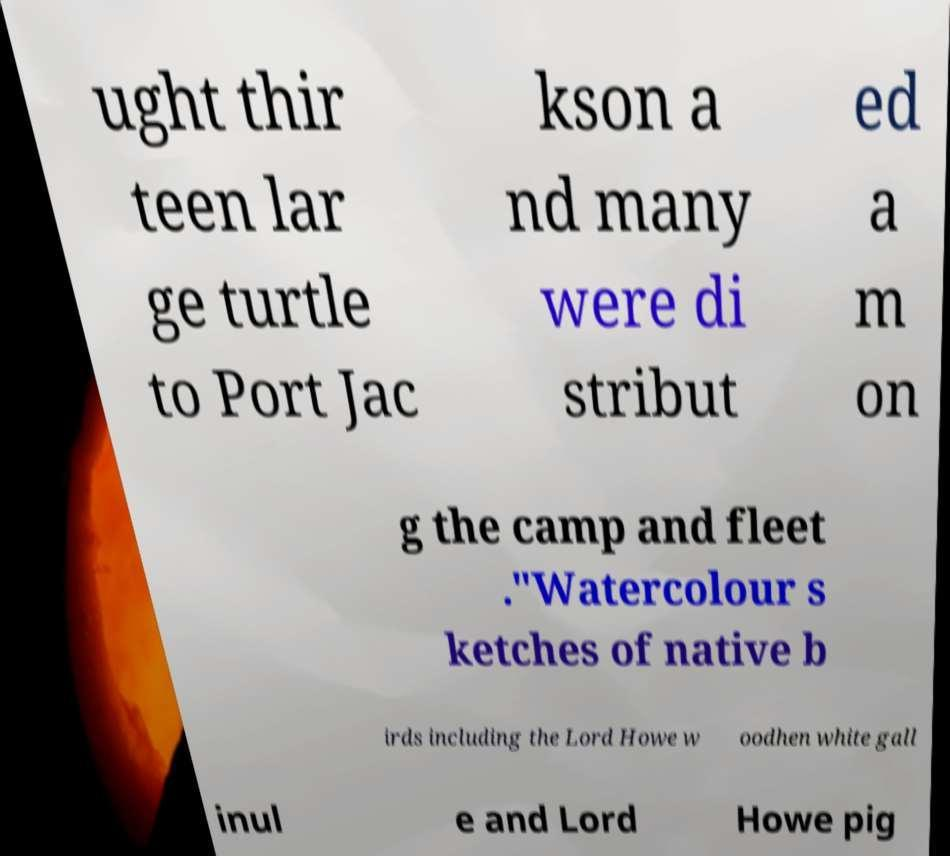For documentation purposes, I need the text within this image transcribed. Could you provide that? ught thir teen lar ge turtle to Port Jac kson a nd many were di stribut ed a m on g the camp and fleet ."Watercolour s ketches of native b irds including the Lord Howe w oodhen white gall inul e and Lord Howe pig 